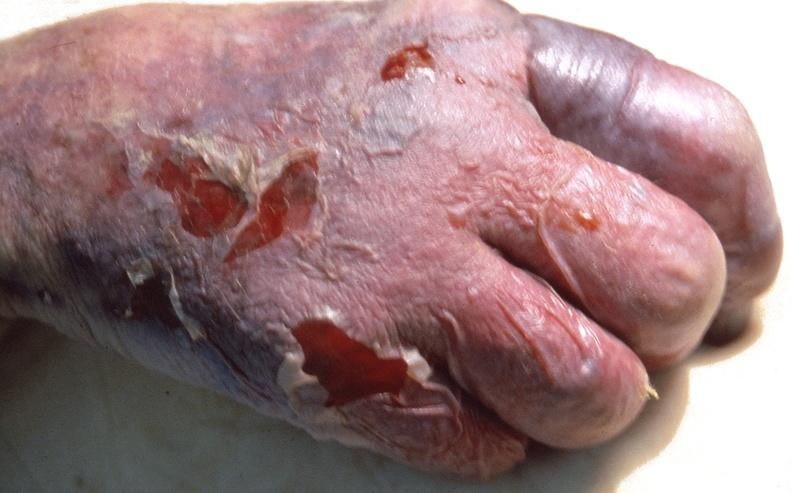why does this image show skin ulceration and necrosis, disseminated intravascular coagulation?
Answer the question using a single word or phrase. Due to acetaminophen toxicity 